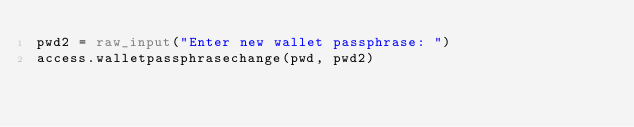<code> <loc_0><loc_0><loc_500><loc_500><_Python_>pwd2 = raw_input("Enter new wallet passphrase: ")
access.walletpassphrasechange(pwd, pwd2)
</code> 